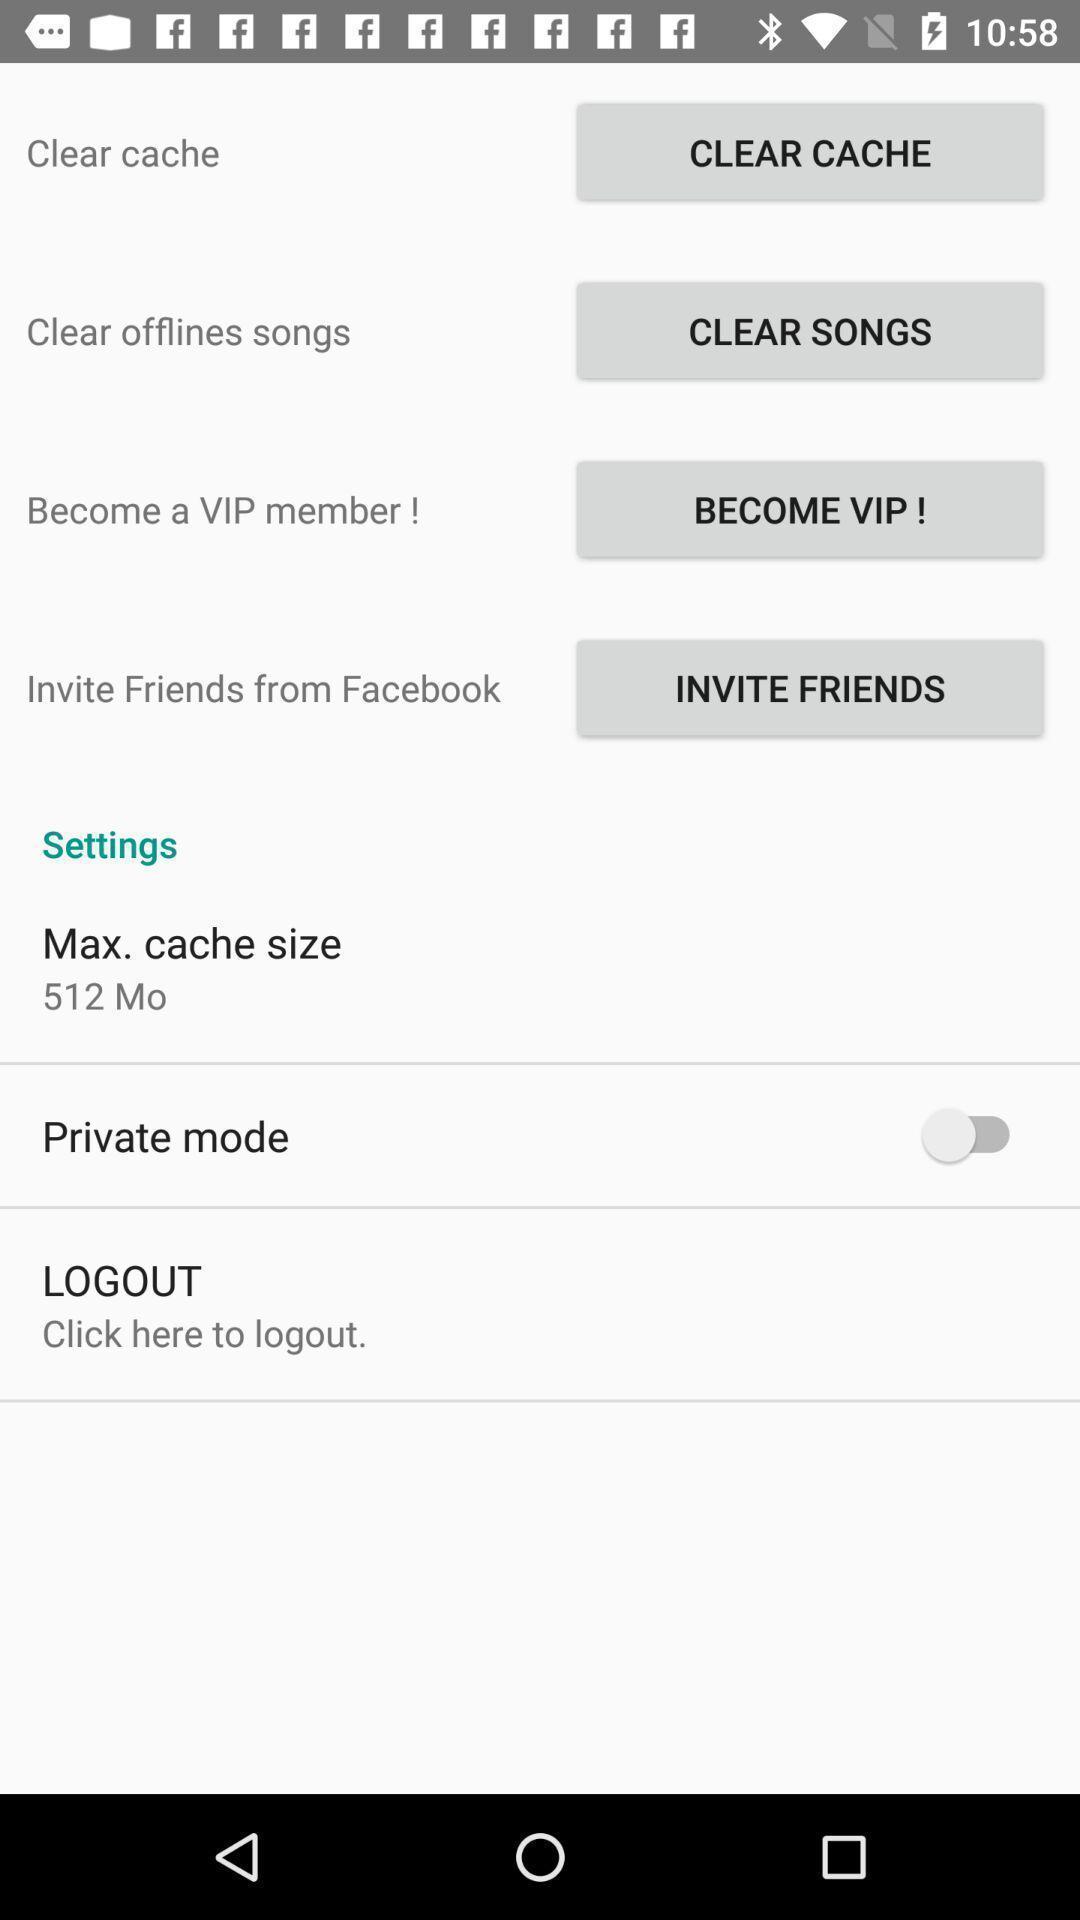Explain what's happening in this screen capture. Page showing multiple options in mobile. 